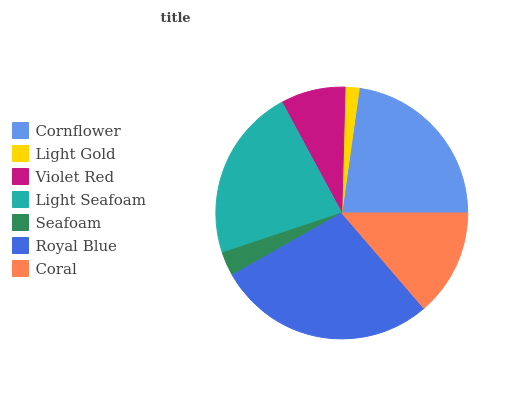Is Light Gold the minimum?
Answer yes or no. Yes. Is Royal Blue the maximum?
Answer yes or no. Yes. Is Violet Red the minimum?
Answer yes or no. No. Is Violet Red the maximum?
Answer yes or no. No. Is Violet Red greater than Light Gold?
Answer yes or no. Yes. Is Light Gold less than Violet Red?
Answer yes or no. Yes. Is Light Gold greater than Violet Red?
Answer yes or no. No. Is Violet Red less than Light Gold?
Answer yes or no. No. Is Coral the high median?
Answer yes or no. Yes. Is Coral the low median?
Answer yes or no. Yes. Is Cornflower the high median?
Answer yes or no. No. Is Light Seafoam the low median?
Answer yes or no. No. 